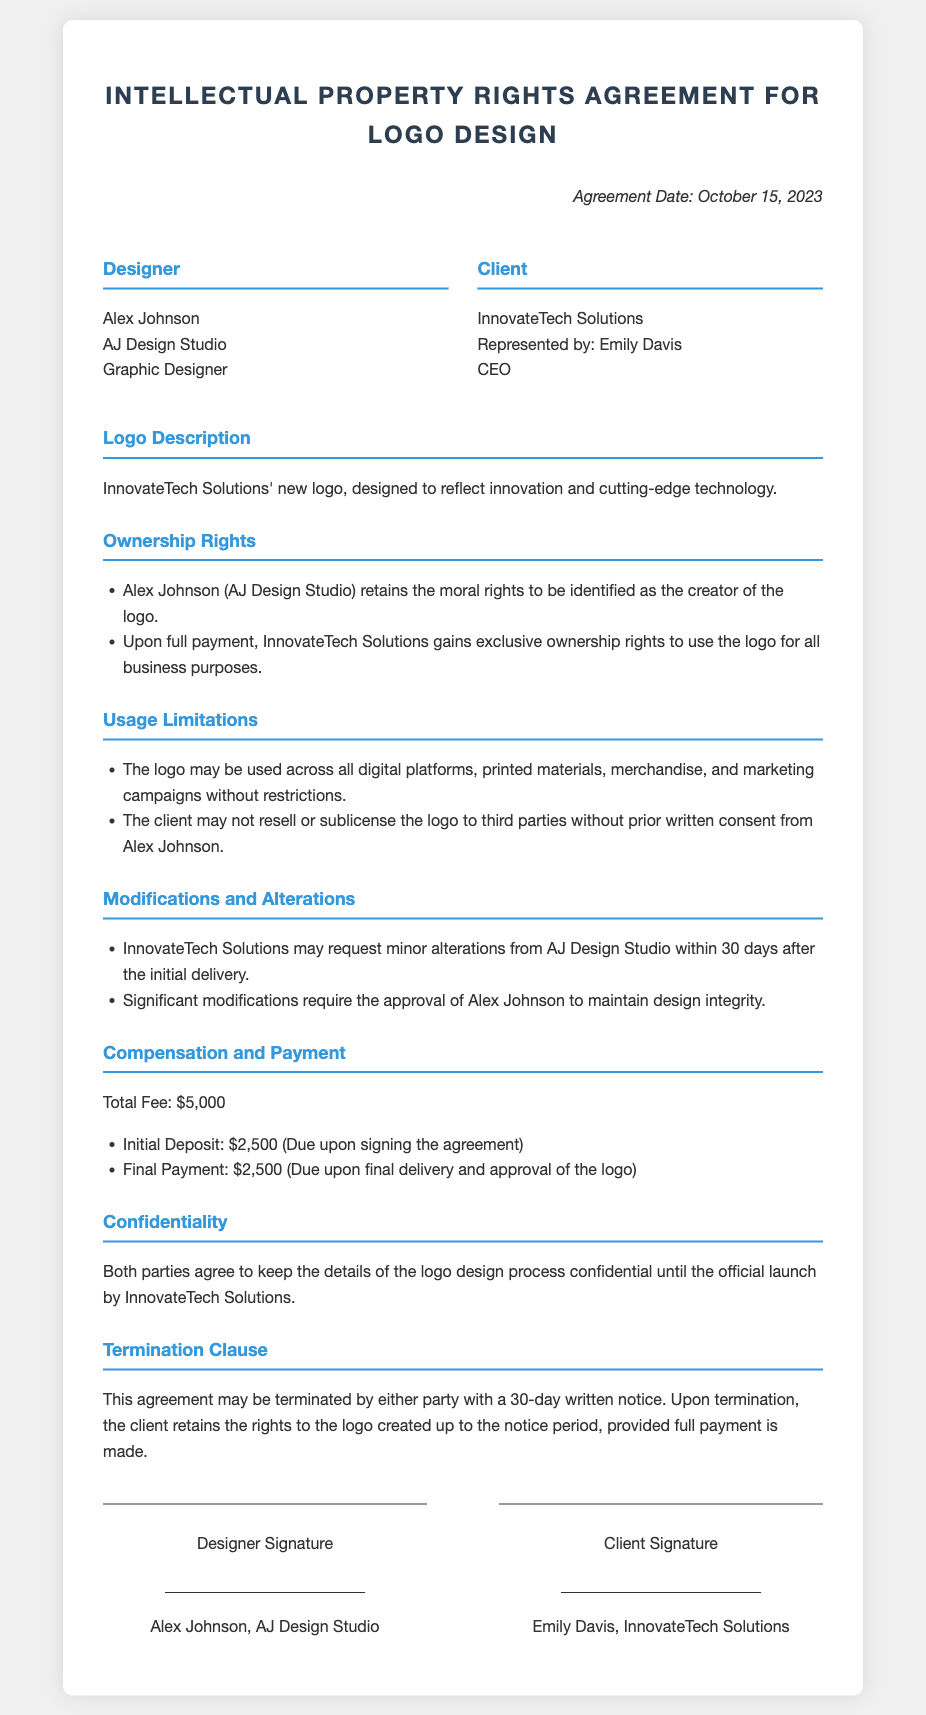What is the agreement date? The agreement date is specified in the document under the date section.
Answer: October 15, 2023 Who is the designer? The designer’s name is mentioned at the beginning of the contract.
Answer: Alex Johnson What is the total fee for the logo design? The total fee is stated clearly in the compensation section of the agreement.
Answer: $5,000 What rights does Alex Johnson retain? The document outlines the rights retained by Alex Johnson under the ownership rights section.
Answer: Moral rights What is required for significant modifications of the logo? The conditions for modifications are detailed in the modifications and alterations section.
Answer: Approval of Alex Johnson Which platforms can the logo be used on? The usage limitations section specifies where the logo may be used.
Answer: All digital platforms How long after initial delivery can InnovateTech Solutions request minor alterations? The timeline for requesting alterations is stated in the modifications section of the agreement.
Answer: 30 days Who can terminate the agreement? The termination clause clarifies who has the authority to terminate the contract.
Answer: Either party What happens if the agreement is terminated? The termination clause provides information about the rights upon termination of the agreement.
Answer: Client retains rights with full payment 